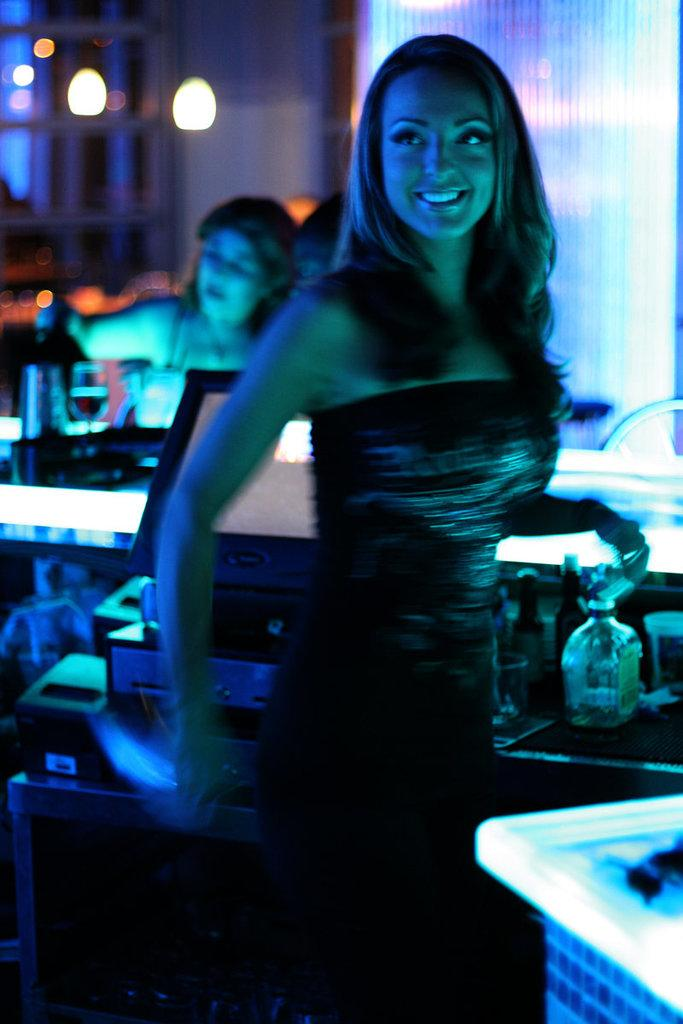What is the primary action of the woman in the image? The woman in the image is standing. How does the standing woman appear to feel? The standing woman is smiling, which suggests she is happy or content. Are there any other people in the image? Yes, there is another woman seated in the image. How many snails can be seen crawling on the woman's shoulder in the image? There are no snails present in the image. What type of trucks are visible in the background of the image? There are no trucks visible in the image. 